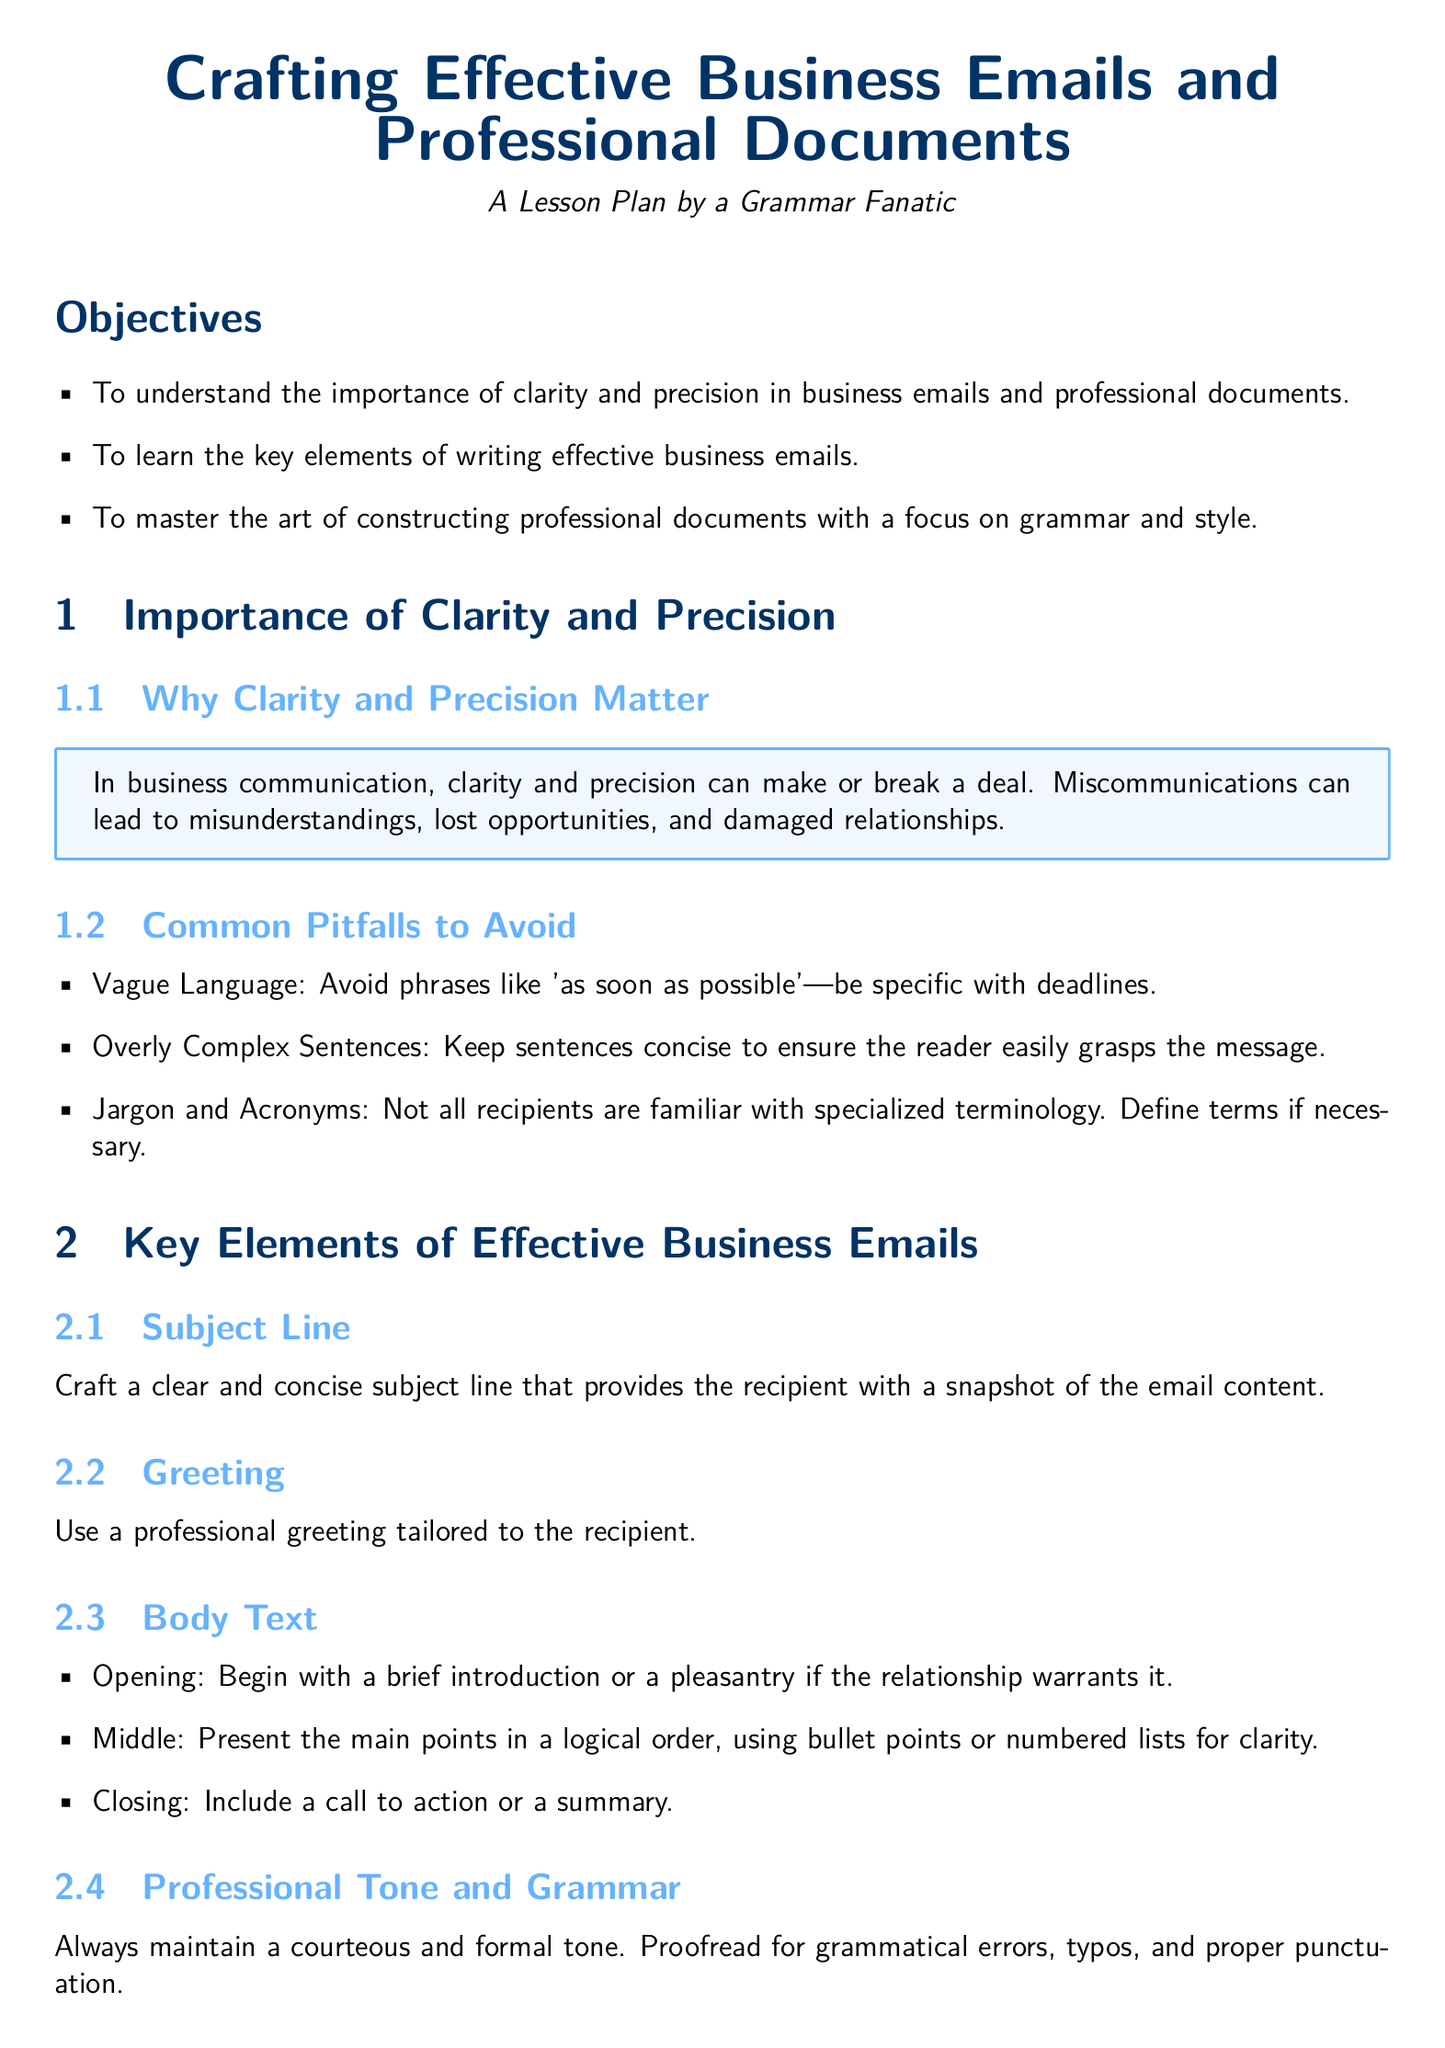What are the three objectives of the lesson plan? The objectives listed include understanding the importance of clarity, learning key elements of writing effective emails, and mastering professional document construction.
Answer: Clarity, key elements, professional documents What is the color used for the main text in the document? The document uses the RGB color 0, 51, 102 for the main text.
Answer: Main color What is one common pitfall to avoid in business emails? The document states that vague language is a common pitfall to avoid in business emails.
Answer: Vague language What should be included in the document structure? The document structure should include a title page and a table of contents.
Answer: Title page, table of contents What is the opening component of the body text in an email? The opening of the body text should include a brief introduction or pleasantry.
Answer: Brief introduction or pleasantry What is emphasized as a crucial aspect of maintaining a professional tone? The document emphasizes the importance of proofreading for grammatical errors.
Answer: Proofreading How should a subject line be crafted? A subject line should be clear and concise, providing a snapshot of the email content.
Answer: Clear and concise What should the conclusion of a professional document summarize? The conclusion should summarize key insights and include recommendations.
Answer: Key insights and recommendations 